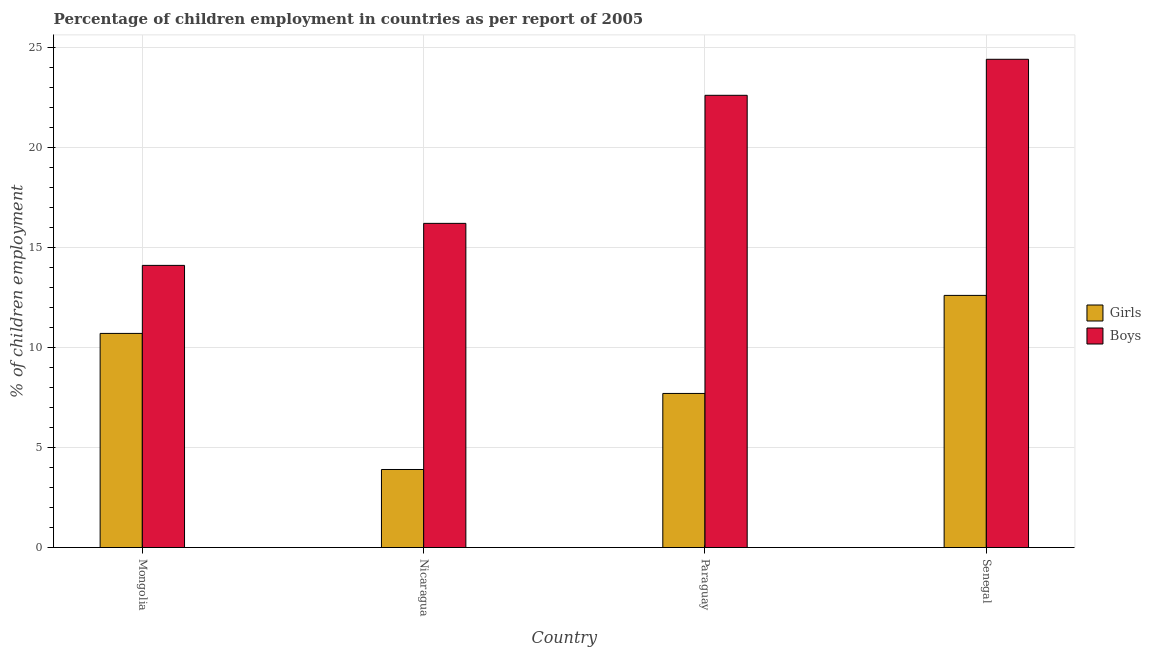How many different coloured bars are there?
Your answer should be very brief. 2. Are the number of bars per tick equal to the number of legend labels?
Provide a short and direct response. Yes. Are the number of bars on each tick of the X-axis equal?
Make the answer very short. Yes. How many bars are there on the 1st tick from the right?
Offer a very short reply. 2. What is the label of the 2nd group of bars from the left?
Offer a very short reply. Nicaragua. Across all countries, what is the maximum percentage of employed boys?
Offer a terse response. 24.4. In which country was the percentage of employed girls maximum?
Provide a short and direct response. Senegal. In which country was the percentage of employed boys minimum?
Offer a very short reply. Mongolia. What is the total percentage of employed girls in the graph?
Offer a terse response. 34.9. What is the difference between the percentage of employed girls in Mongolia and that in Nicaragua?
Keep it short and to the point. 6.8. What is the difference between the percentage of employed boys in Nicaragua and the percentage of employed girls in Mongolia?
Provide a succinct answer. 5.5. What is the average percentage of employed girls per country?
Keep it short and to the point. 8.72. What is the difference between the percentage of employed girls and percentage of employed boys in Senegal?
Provide a short and direct response. -11.8. What is the ratio of the percentage of employed girls in Paraguay to that in Senegal?
Make the answer very short. 0.61. Is the percentage of employed girls in Nicaragua less than that in Paraguay?
Give a very brief answer. Yes. What is the difference between the highest and the second highest percentage of employed girls?
Keep it short and to the point. 1.9. What is the difference between the highest and the lowest percentage of employed girls?
Your answer should be very brief. 8.7. In how many countries, is the percentage of employed girls greater than the average percentage of employed girls taken over all countries?
Offer a very short reply. 2. Is the sum of the percentage of employed boys in Mongolia and Nicaragua greater than the maximum percentage of employed girls across all countries?
Ensure brevity in your answer.  Yes. What does the 2nd bar from the left in Nicaragua represents?
Offer a terse response. Boys. What does the 1st bar from the right in Nicaragua represents?
Make the answer very short. Boys. How many bars are there?
Your response must be concise. 8. How many countries are there in the graph?
Your response must be concise. 4. Are the values on the major ticks of Y-axis written in scientific E-notation?
Offer a very short reply. No. Does the graph contain grids?
Provide a succinct answer. Yes. Where does the legend appear in the graph?
Provide a short and direct response. Center right. How many legend labels are there?
Give a very brief answer. 2. How are the legend labels stacked?
Provide a succinct answer. Vertical. What is the title of the graph?
Provide a short and direct response. Percentage of children employment in countries as per report of 2005. Does "Grants" appear as one of the legend labels in the graph?
Give a very brief answer. No. What is the label or title of the Y-axis?
Offer a terse response. % of children employment. What is the % of children employment in Girls in Mongolia?
Your answer should be compact. 10.7. What is the % of children employment in Boys in Mongolia?
Your answer should be very brief. 14.1. What is the % of children employment of Boys in Paraguay?
Ensure brevity in your answer.  22.6. What is the % of children employment in Boys in Senegal?
Provide a succinct answer. 24.4. Across all countries, what is the maximum % of children employment of Boys?
Provide a short and direct response. 24.4. What is the total % of children employment in Girls in the graph?
Keep it short and to the point. 34.9. What is the total % of children employment of Boys in the graph?
Offer a very short reply. 77.3. What is the difference between the % of children employment of Girls in Nicaragua and that in Paraguay?
Give a very brief answer. -3.8. What is the difference between the % of children employment in Boys in Nicaragua and that in Senegal?
Give a very brief answer. -8.2. What is the difference between the % of children employment of Girls in Paraguay and that in Senegal?
Offer a terse response. -4.9. What is the difference between the % of children employment in Boys in Paraguay and that in Senegal?
Your response must be concise. -1.8. What is the difference between the % of children employment in Girls in Mongolia and the % of children employment in Boys in Nicaragua?
Your answer should be very brief. -5.5. What is the difference between the % of children employment of Girls in Mongolia and the % of children employment of Boys in Senegal?
Give a very brief answer. -13.7. What is the difference between the % of children employment of Girls in Nicaragua and the % of children employment of Boys in Paraguay?
Your answer should be very brief. -18.7. What is the difference between the % of children employment of Girls in Nicaragua and the % of children employment of Boys in Senegal?
Keep it short and to the point. -20.5. What is the difference between the % of children employment of Girls in Paraguay and the % of children employment of Boys in Senegal?
Ensure brevity in your answer.  -16.7. What is the average % of children employment of Girls per country?
Give a very brief answer. 8.72. What is the average % of children employment of Boys per country?
Your answer should be very brief. 19.32. What is the difference between the % of children employment in Girls and % of children employment in Boys in Paraguay?
Ensure brevity in your answer.  -14.9. What is the ratio of the % of children employment in Girls in Mongolia to that in Nicaragua?
Offer a terse response. 2.74. What is the ratio of the % of children employment in Boys in Mongolia to that in Nicaragua?
Offer a terse response. 0.87. What is the ratio of the % of children employment in Girls in Mongolia to that in Paraguay?
Provide a short and direct response. 1.39. What is the ratio of the % of children employment of Boys in Mongolia to that in Paraguay?
Offer a very short reply. 0.62. What is the ratio of the % of children employment of Girls in Mongolia to that in Senegal?
Your response must be concise. 0.85. What is the ratio of the % of children employment in Boys in Mongolia to that in Senegal?
Your answer should be very brief. 0.58. What is the ratio of the % of children employment of Girls in Nicaragua to that in Paraguay?
Provide a short and direct response. 0.51. What is the ratio of the % of children employment of Boys in Nicaragua to that in Paraguay?
Offer a very short reply. 0.72. What is the ratio of the % of children employment of Girls in Nicaragua to that in Senegal?
Your answer should be very brief. 0.31. What is the ratio of the % of children employment of Boys in Nicaragua to that in Senegal?
Ensure brevity in your answer.  0.66. What is the ratio of the % of children employment of Girls in Paraguay to that in Senegal?
Provide a succinct answer. 0.61. What is the ratio of the % of children employment of Boys in Paraguay to that in Senegal?
Your response must be concise. 0.93. What is the difference between the highest and the second highest % of children employment of Boys?
Make the answer very short. 1.8. 